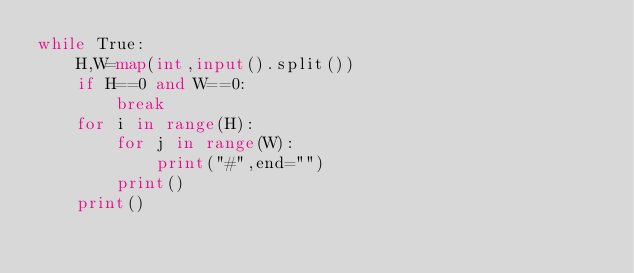<code> <loc_0><loc_0><loc_500><loc_500><_Python_>while True:
    H,W=map(int,input().split())
    if H==0 and W==0:
        break
    for i in range(H):
        for j in range(W):
            print("#",end="")
        print()
    print()    

</code> 